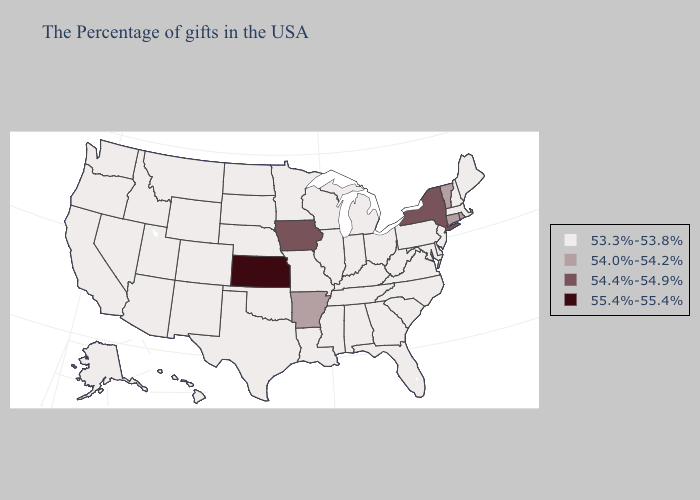What is the value of Virginia?
Be succinct. 53.3%-53.8%. Does Pennsylvania have the highest value in the Northeast?
Be succinct. No. Does Missouri have a lower value than Alaska?
Answer briefly. No. What is the highest value in the MidWest ?
Be succinct. 55.4%-55.4%. Name the states that have a value in the range 53.3%-53.8%?
Short answer required. Maine, Massachusetts, New Hampshire, New Jersey, Delaware, Maryland, Pennsylvania, Virginia, North Carolina, South Carolina, West Virginia, Ohio, Florida, Georgia, Michigan, Kentucky, Indiana, Alabama, Tennessee, Wisconsin, Illinois, Mississippi, Louisiana, Missouri, Minnesota, Nebraska, Oklahoma, Texas, South Dakota, North Dakota, Wyoming, Colorado, New Mexico, Utah, Montana, Arizona, Idaho, Nevada, California, Washington, Oregon, Alaska, Hawaii. What is the value of North Carolina?
Keep it brief. 53.3%-53.8%. What is the value of Louisiana?
Write a very short answer. 53.3%-53.8%. What is the value of Vermont?
Short answer required. 54.0%-54.2%. What is the highest value in the South ?
Answer briefly. 54.0%-54.2%. Does New York have the highest value in the Northeast?
Keep it brief. Yes. Does the first symbol in the legend represent the smallest category?
Be succinct. Yes. Name the states that have a value in the range 54.4%-54.9%?
Keep it brief. New York, Iowa. What is the value of South Carolina?
Quick response, please. 53.3%-53.8%. What is the lowest value in the South?
Short answer required. 53.3%-53.8%. 